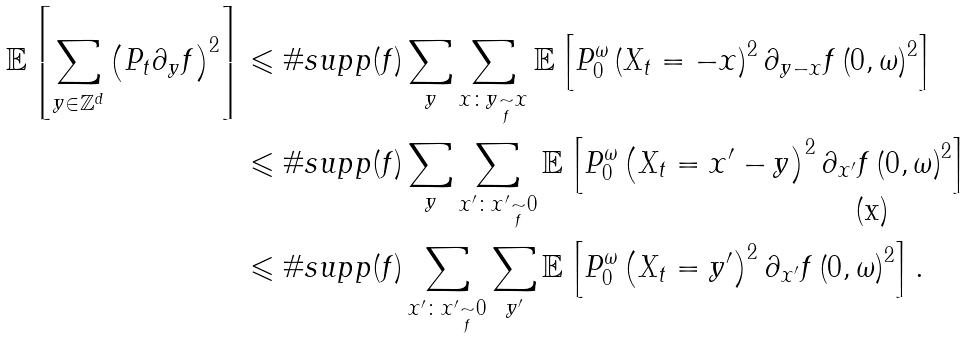<formula> <loc_0><loc_0><loc_500><loc_500>\mathbb { E } \left [ \sum _ { y \in \mathbb { Z } ^ { d } } \left ( P _ { t } \partial _ { y } f \right ) ^ { 2 } \right ] & \leqslant \# s u p p ( f ) \sum _ { y } \sum _ { x \colon y \underset { f } { \sim } x } \mathbb { E } \left [ P _ { 0 } ^ { \omega } \left ( X _ { t } = - x \right ) ^ { 2 } \partial _ { y - x } f \left ( 0 , \omega \right ) ^ { 2 } \right ] \\ & \leqslant \# s u p p ( f ) \sum _ { y } \sum _ { x ^ { \prime } \colon x ^ { \prime } \underset { f } { \sim } 0 } \mathbb { E } \left [ P _ { 0 } ^ { \omega } \left ( X _ { t } = x ^ { \prime } - y \right ) ^ { 2 } \partial _ { x ^ { \prime } } f \left ( 0 , \omega \right ) ^ { 2 } \right ] \\ & \leqslant \# s u p p ( f ) \sum _ { x ^ { \prime } \colon x ^ { \prime } \underset { f } { \sim } 0 } \sum _ { y ^ { \prime } } \mathbb { E } \left [ P _ { 0 } ^ { \omega } \left ( X _ { t } = y ^ { \prime } \right ) ^ { 2 } \partial _ { x ^ { \prime } } f \left ( 0 , \omega \right ) ^ { 2 } \right ] .</formula> 